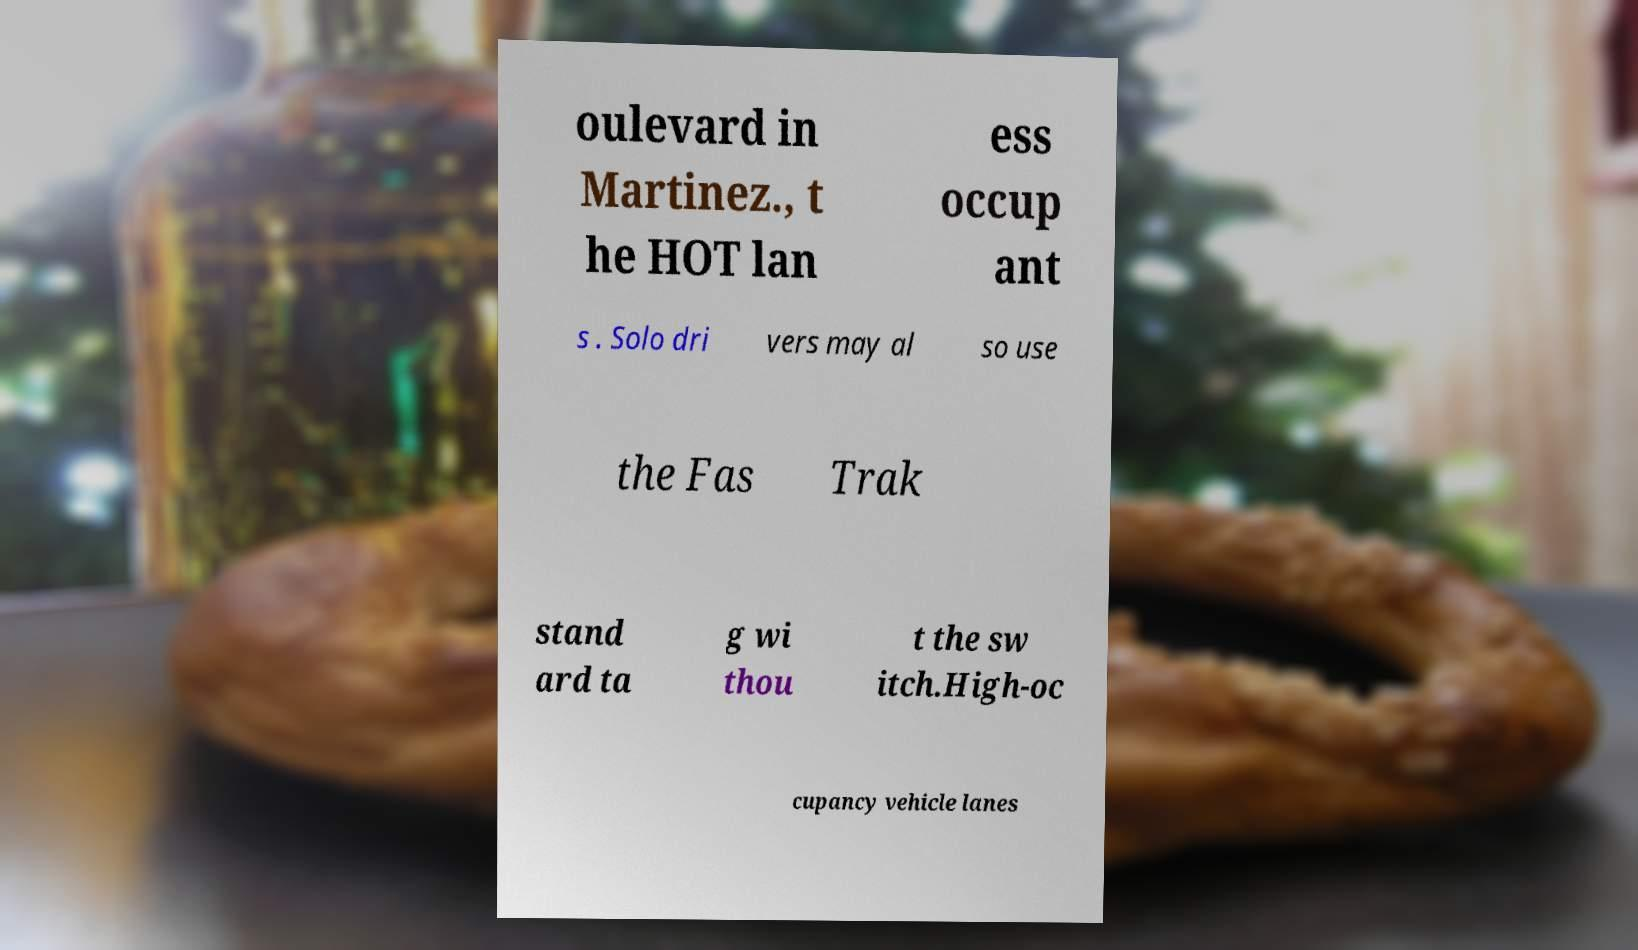Can you read and provide the text displayed in the image?This photo seems to have some interesting text. Can you extract and type it out for me? oulevard in Martinez., t he HOT lan ess occup ant s . Solo dri vers may al so use the Fas Trak stand ard ta g wi thou t the sw itch.High-oc cupancy vehicle lanes 